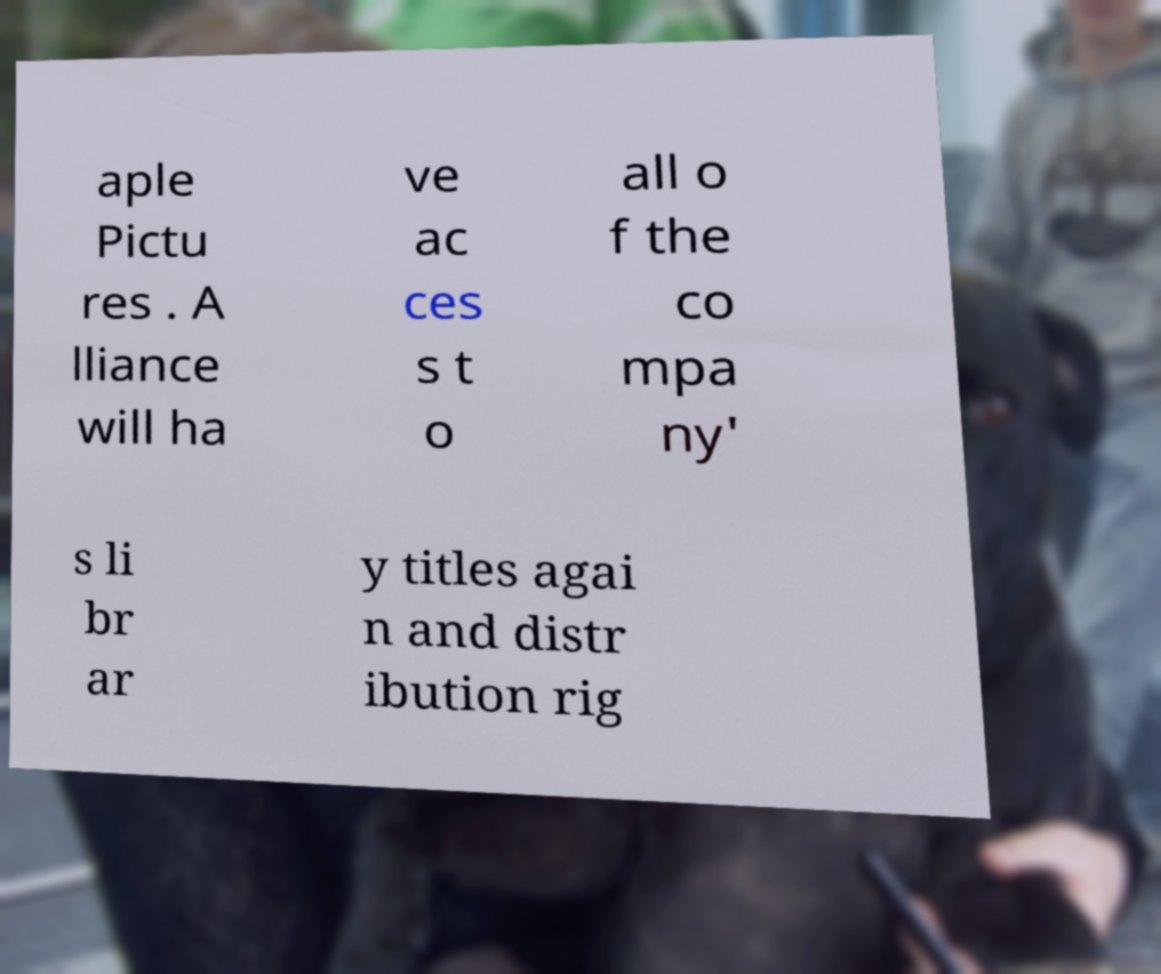Please identify and transcribe the text found in this image. aple Pictu res . A lliance will ha ve ac ces s t o all o f the co mpa ny' s li br ar y titles agai n and distr ibution rig 